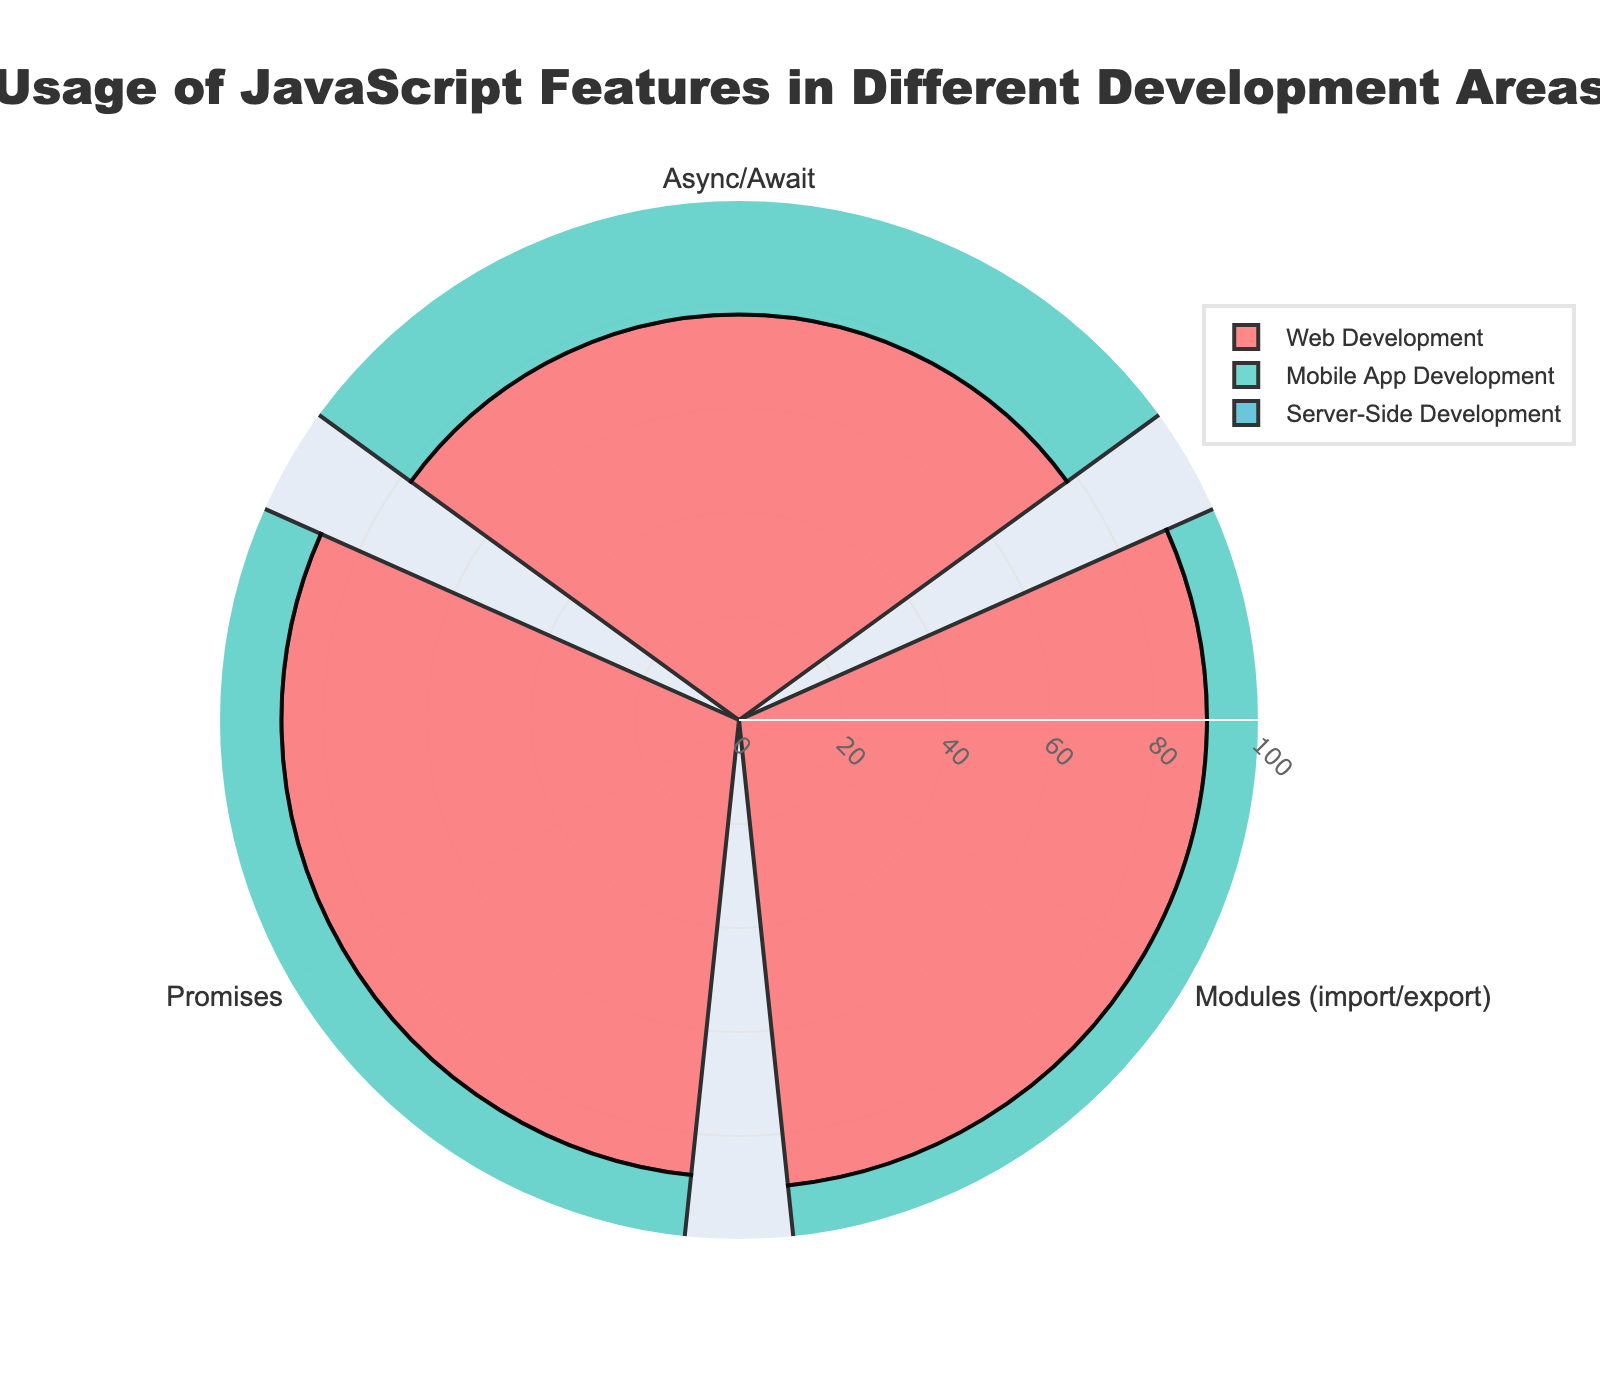What's the title of the figure? The title can be seen at the top center of the figure.
Answer: Usage of JavaScript Features in Different Development Areas Which feature has the highest usage in Web Development? By looking at the radial values for each feature within the Web Development group, the one with the highest value is the highest bar.
Answer: Modules (import/export) What is the combined usage of Promises in all three development areas? Add the usage values of Promises in Web Development, Mobile App Development, and Server-Side Development: 88 + 80 + 72.
Answer: 240 How does the usage of Async/Await compare between Mobile App Development and Server-Side Development? Check the radial values for Async/Await in both categories and compare: 82 (Mobile App) vs. 70 (Server-Side).
Answer: Mobile App Development has higher usage Which feature has the least variation in usage across the three development areas? Calculate the range (max - min) for each feature's usage values and identify the one with the smallest difference.
Answer: Promises How much more is Modules (import/export) used in Web Development compared to Server-Side Development? Subtract the usage value of Modules in Server-Side Development from its value in Web Development: 90 - 60.
Answer: 30 What is the average usage of Async/Await across all three development areas? Compute the average by summing the values and dividing by 3: (78 + 82 + 70) / 3.
Answer: 76.67 Which category shows the highest usage for Promises? Identify the feature's value in each category and find the highest one.
Answer: Web Development Is there any feature that has the same usage percentage in any two development areas? Compare the usage percentages for each feature across development areas; no values should match.
Answer: No What is the lowest usage value among all features and categories? Identify the smallest value across the entire data set.
Answer: 60 